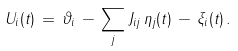Convert formula to latex. <formula><loc_0><loc_0><loc_500><loc_500>U _ { i } ( t ) \, = \, \vartheta _ { i } \, - \, \sum _ { j } J _ { i j } \, \eta _ { j } ( t ) \, - \, \xi _ { i } ( t ) \, .</formula> 